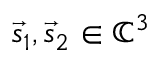Convert formula to latex. <formula><loc_0><loc_0><loc_500><loc_500>\vec { s } _ { 1 } , \vec { s } _ { 2 } \in \mathbb { C } ^ { 3 }</formula> 